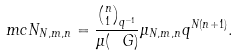<formula> <loc_0><loc_0><loc_500><loc_500>\ m c N _ { N , m , n } = \frac { \binom { n } { 1 } _ { q ^ { - 1 } } } { \mu ( \ G ) } \mu _ { N , m , n } q ^ { N ( n + 1 ) } .</formula> 